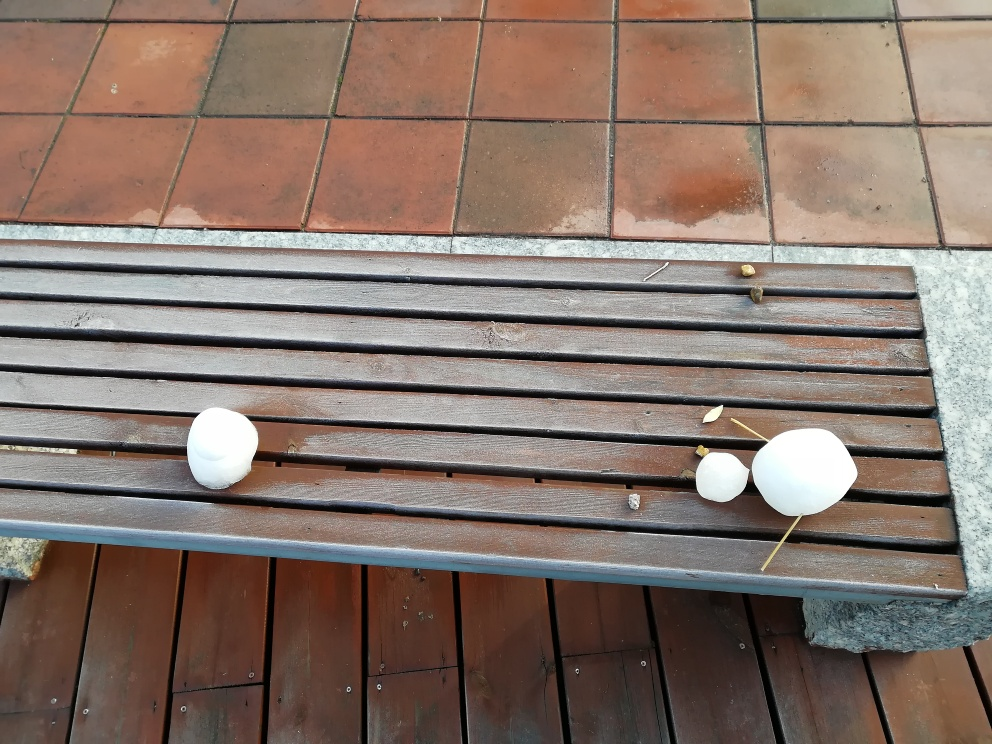What does the high color saturation indicate? High color saturation indicates that the colors in the image are very intense and vivid. This usually means the colors are very pure and have less blending with grays, making the image appear more vibrant and striking. 